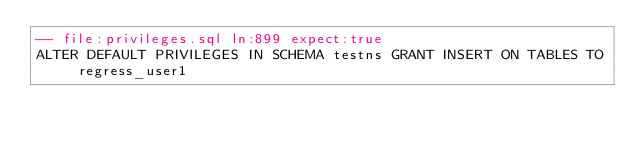<code> <loc_0><loc_0><loc_500><loc_500><_SQL_>-- file:privileges.sql ln:899 expect:true
ALTER DEFAULT PRIVILEGES IN SCHEMA testns GRANT INSERT ON TABLES TO regress_user1
</code> 